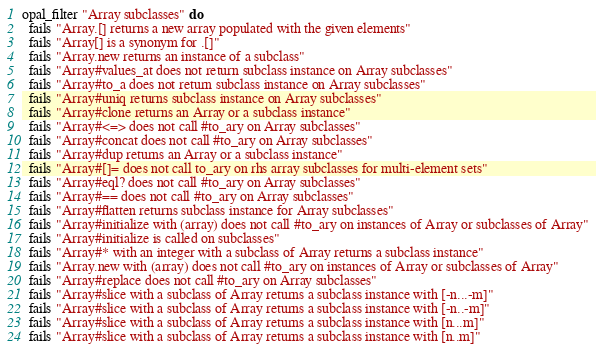<code> <loc_0><loc_0><loc_500><loc_500><_Ruby_>opal_filter "Array subclasses" do
  fails "Array.[] returns a new array populated with the given elements"
  fails "Array[] is a synonym for .[]"
  fails "Array.new returns an instance of a subclass"
  fails "Array#values_at does not return subclass instance on Array subclasses"
  fails "Array#to_a does not return subclass instance on Array subclasses"
  fails "Array#uniq returns subclass instance on Array subclasses"
  fails "Array#clone returns an Array or a subclass instance"
  fails "Array#<=> does not call #to_ary on Array subclasses"
  fails "Array#concat does not call #to_ary on Array subclasses"
  fails "Array#dup returns an Array or a subclass instance"
  fails "Array#[]= does not call to_ary on rhs array subclasses for multi-element sets"
  fails "Array#eql? does not call #to_ary on Array subclasses"
  fails "Array#== does not call #to_ary on Array subclasses"
  fails "Array#flatten returns subclass instance for Array subclasses"
  fails "Array#initialize with (array) does not call #to_ary on instances of Array or subclasses of Array"
  fails "Array#initialize is called on subclasses"
  fails "Array#* with an integer with a subclass of Array returns a subclass instance"
  fails "Array.new with (array) does not call #to_ary on instances of Array or subclasses of Array"
  fails "Array#replace does not call #to_ary on Array subclasses"
  fails "Array#slice with a subclass of Array returns a subclass instance with [-n...-m]"
  fails "Array#slice with a subclass of Array returns a subclass instance with [-n..-m]"
  fails "Array#slice with a subclass of Array returns a subclass instance with [n...m]"
  fails "Array#slice with a subclass of Array returns a subclass instance with [n..m]"</code> 